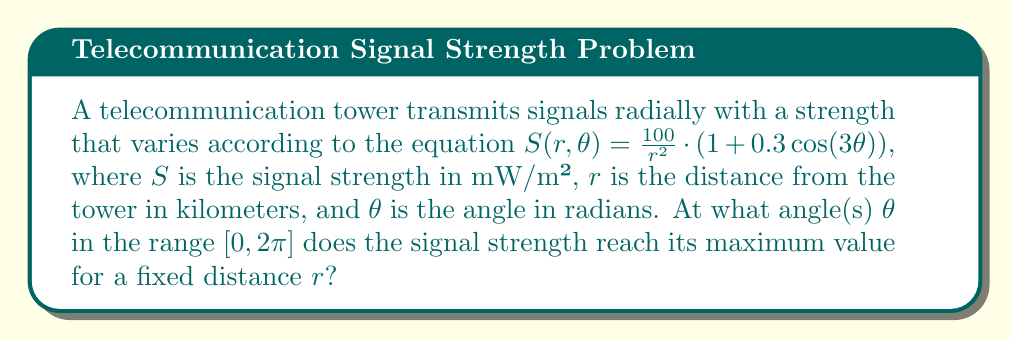Solve this math problem. To find the angles where the signal strength reaches its maximum value, we need to analyze the angular component of the given equation:

1) The signal strength equation is $S(r,\theta) = \frac{100}{r^2} \cdot (1 + 0.3\cos(3\theta))$

2) For a fixed distance $r$, the term $\frac{100}{r^2}$ is constant. Let's call this constant $C$. So we can simplify our analysis to:

   $S(\theta) = C \cdot (1 + 0.3\cos(3\theta))$

3) The maximum value of this function will occur when $\cos(3\theta)$ is at its maximum, which is 1.

4) $\cos(3\theta) = 1$ when $3\theta = 0, 2\pi, 4\pi, ...$

5) Solving for $\theta$:
   $\theta = 0, \frac{2\pi}{3}, \frac{4\pi}{3}, 2\pi$

6) In the range $[0, 2\pi]$, the solutions are:
   $\theta = 0, \frac{2\pi}{3}, \frac{4\pi}{3}, 2\pi$

These angles correspond to the directions where the signal strength is maximum for any given distance from the tower.
Answer: The signal strength reaches its maximum value at angles $\theta = 0, \frac{2\pi}{3}, \frac{4\pi}{3},$ and $2\pi$ radians. 